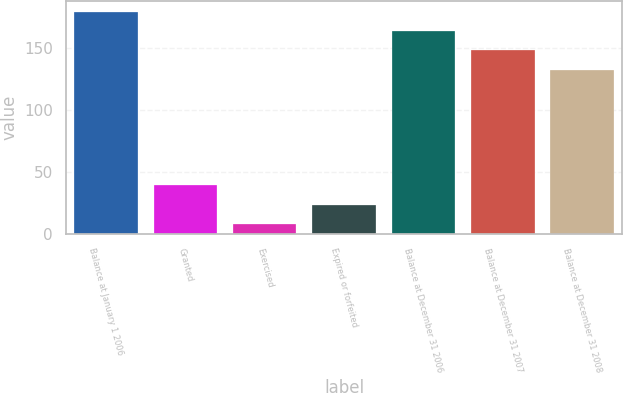Convert chart. <chart><loc_0><loc_0><loc_500><loc_500><bar_chart><fcel>Balance at January 1 2006<fcel>Granted<fcel>Exercised<fcel>Expired or forfeited<fcel>Balance at December 31 2006<fcel>Balance at December 31 2007<fcel>Balance at December 31 2008<nl><fcel>179.2<fcel>39.2<fcel>8<fcel>23.6<fcel>163.6<fcel>148<fcel>132<nl></chart> 